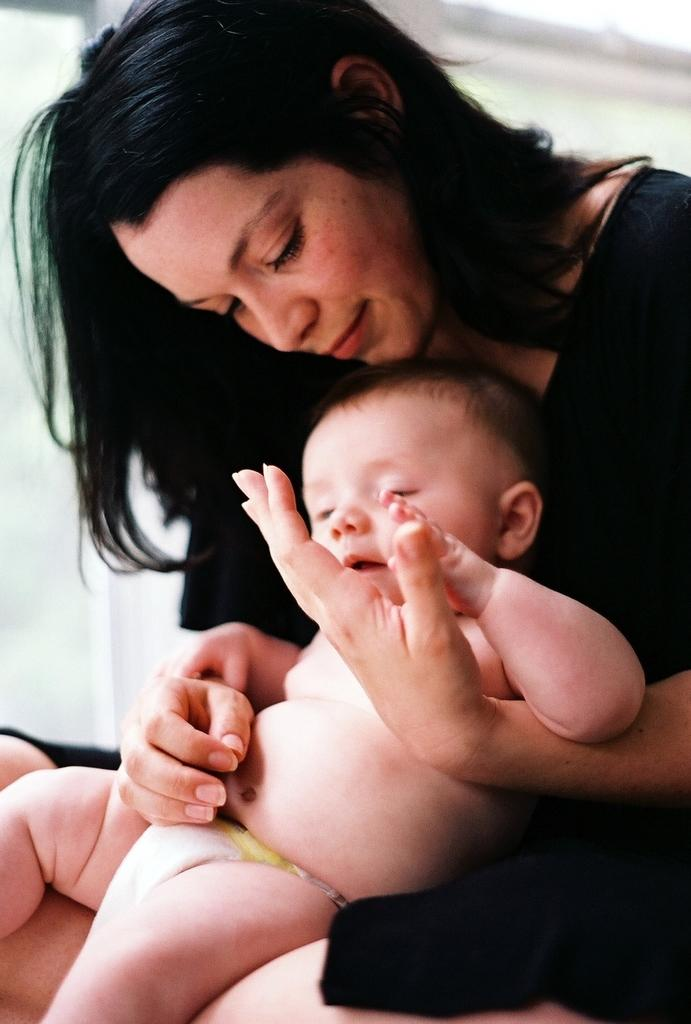Who is the main subject in the image? There is a woman in the image. What is the woman wearing? The woman is wearing a black dress. What is the woman doing in the image? The woman is sitting and holding a baby. What can be seen in the background of the image? There appears to be a window in the background of the image. What type of pet can be seen playing with a button in the image? There is no pet or button present in the image. Is the woman performing on a stage in the image? There is no stage present in the image; the woman is sitting in a setting with a window in the background. 